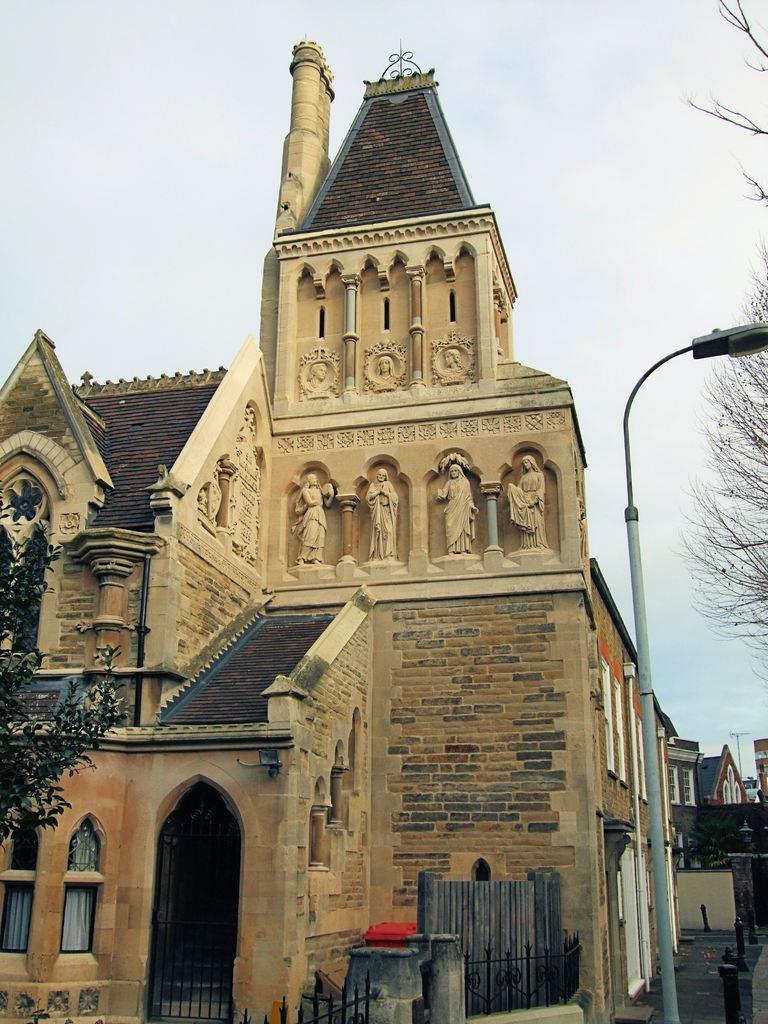In one or two sentences, can you explain what this image depicts? In this image we can see the roof houses. We can also see the fence, sculptures, light pole and also the tree on the right. In the background we can see the sky. On the left we can also see the tree. 